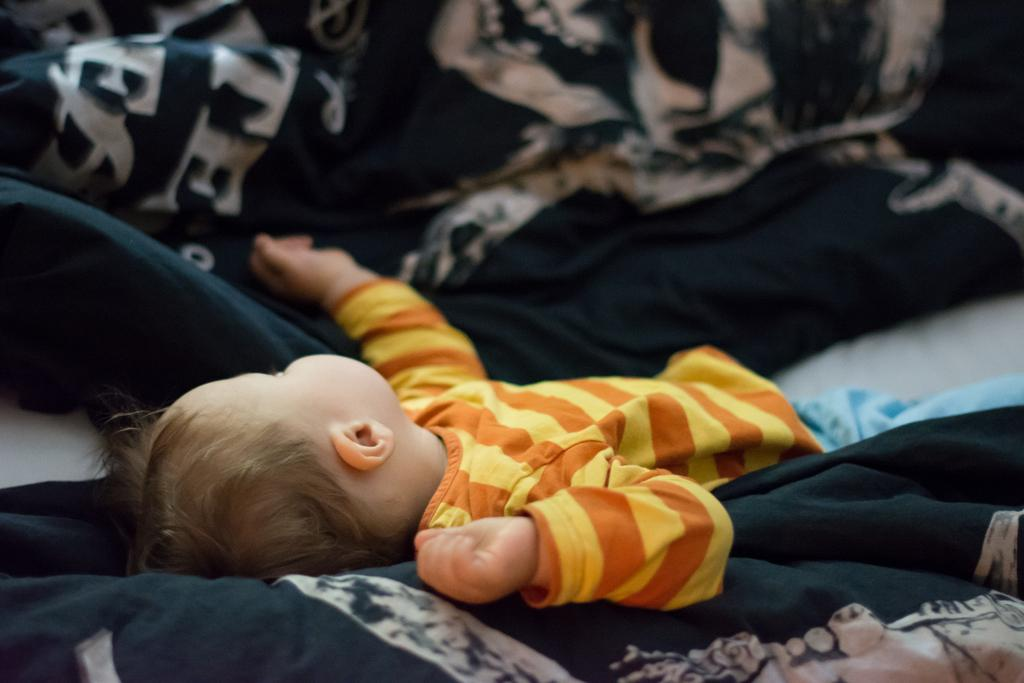What is the main subject of the image? There is a baby in the image. What is the baby doing in the image? The baby is sleeping. What color combination is the baby's shirt in the image? The baby is wearing a yellow and orange color shirt. What type of covering is present in the image? There is a black color blanket in the image. What date is circled on the calendar in the image? There is no calendar present in the image. What word is written on the baby's forehead in the image? There are no words written on the baby's forehead in the image. 